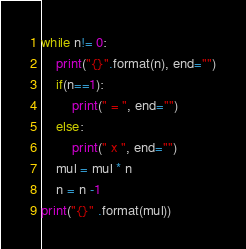Convert code to text. <code><loc_0><loc_0><loc_500><loc_500><_Python_>while n!= 0:
    print("{}".format(n), end="")
    if(n==1):
        print(" = ", end="")
    else:
        print(" x ", end="")
    mul = mul * n
    n = n -1
print("{}" .format(mul))</code> 